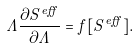<formula> <loc_0><loc_0><loc_500><loc_500>\Lambda \frac { \partial S ^ { e f f } } { \partial \Lambda } = f [ S ^ { e f f } ] .</formula> 